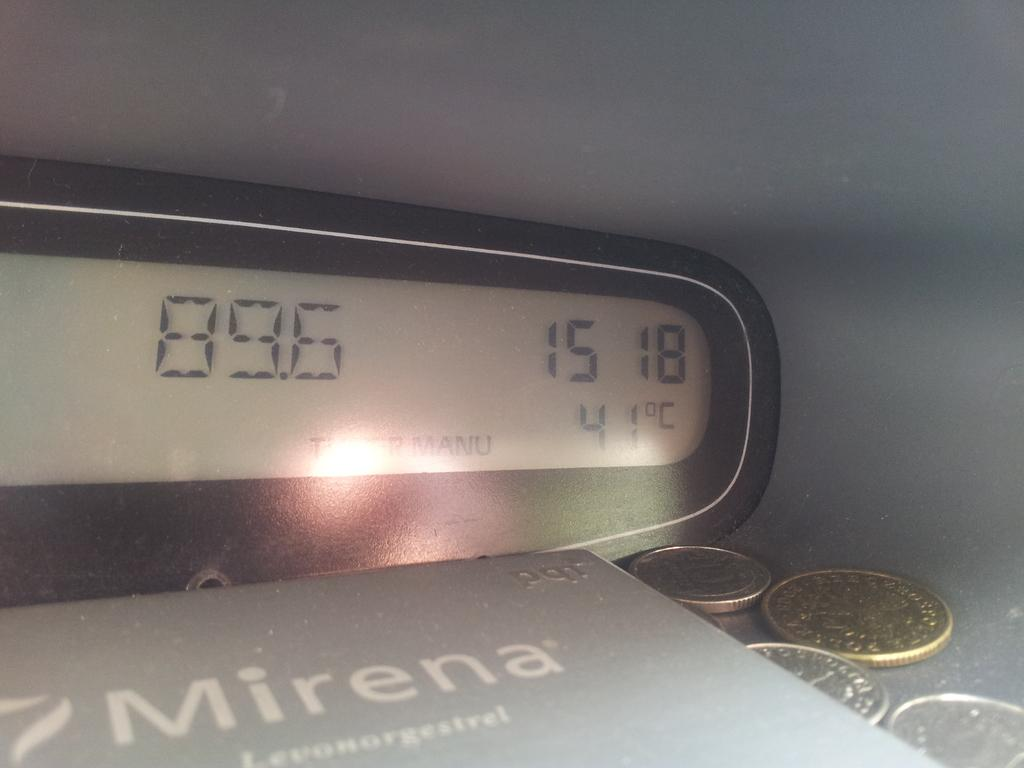<image>
Render a clear and concise summary of the photo. a radio dial showing the station, time and temperature next to a book and some change. 